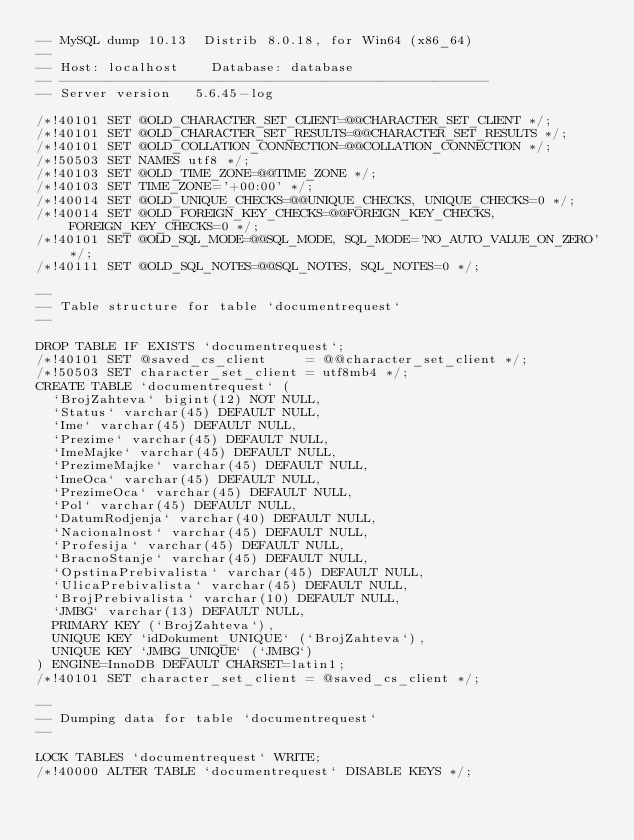<code> <loc_0><loc_0><loc_500><loc_500><_SQL_>-- MySQL dump 10.13  Distrib 8.0.18, for Win64 (x86_64)
--
-- Host: localhost    Database: database
-- ------------------------------------------------------
-- Server version	5.6.45-log

/*!40101 SET @OLD_CHARACTER_SET_CLIENT=@@CHARACTER_SET_CLIENT */;
/*!40101 SET @OLD_CHARACTER_SET_RESULTS=@@CHARACTER_SET_RESULTS */;
/*!40101 SET @OLD_COLLATION_CONNECTION=@@COLLATION_CONNECTION */;
/*!50503 SET NAMES utf8 */;
/*!40103 SET @OLD_TIME_ZONE=@@TIME_ZONE */;
/*!40103 SET TIME_ZONE='+00:00' */;
/*!40014 SET @OLD_UNIQUE_CHECKS=@@UNIQUE_CHECKS, UNIQUE_CHECKS=0 */;
/*!40014 SET @OLD_FOREIGN_KEY_CHECKS=@@FOREIGN_KEY_CHECKS, FOREIGN_KEY_CHECKS=0 */;
/*!40101 SET @OLD_SQL_MODE=@@SQL_MODE, SQL_MODE='NO_AUTO_VALUE_ON_ZERO' */;
/*!40111 SET @OLD_SQL_NOTES=@@SQL_NOTES, SQL_NOTES=0 */;

--
-- Table structure for table `documentrequest`
--

DROP TABLE IF EXISTS `documentrequest`;
/*!40101 SET @saved_cs_client     = @@character_set_client */;
/*!50503 SET character_set_client = utf8mb4 */;
CREATE TABLE `documentrequest` (
  `BrojZahteva` bigint(12) NOT NULL,
  `Status` varchar(45) DEFAULT NULL,
  `Ime` varchar(45) DEFAULT NULL,
  `Prezime` varchar(45) DEFAULT NULL,
  `ImeMajke` varchar(45) DEFAULT NULL,
  `PrezimeMajke` varchar(45) DEFAULT NULL,
  `ImeOca` varchar(45) DEFAULT NULL,
  `PrezimeOca` varchar(45) DEFAULT NULL,
  `Pol` varchar(45) DEFAULT NULL,
  `DatumRodjenja` varchar(40) DEFAULT NULL,
  `Nacionalnost` varchar(45) DEFAULT NULL,
  `Profesija` varchar(45) DEFAULT NULL,
  `BracnoStanje` varchar(45) DEFAULT NULL,
  `OpstinaPrebivalista` varchar(45) DEFAULT NULL,
  `UlicaPrebivalista` varchar(45) DEFAULT NULL,
  `BrojPrebivalista` varchar(10) DEFAULT NULL,
  `JMBG` varchar(13) DEFAULT NULL,
  PRIMARY KEY (`BrojZahteva`),
  UNIQUE KEY `idDokument_UNIQUE` (`BrojZahteva`),
  UNIQUE KEY `JMBG_UNIQUE` (`JMBG`)
) ENGINE=InnoDB DEFAULT CHARSET=latin1;
/*!40101 SET character_set_client = @saved_cs_client */;

--
-- Dumping data for table `documentrequest`
--

LOCK TABLES `documentrequest` WRITE;
/*!40000 ALTER TABLE `documentrequest` DISABLE KEYS */;</code> 